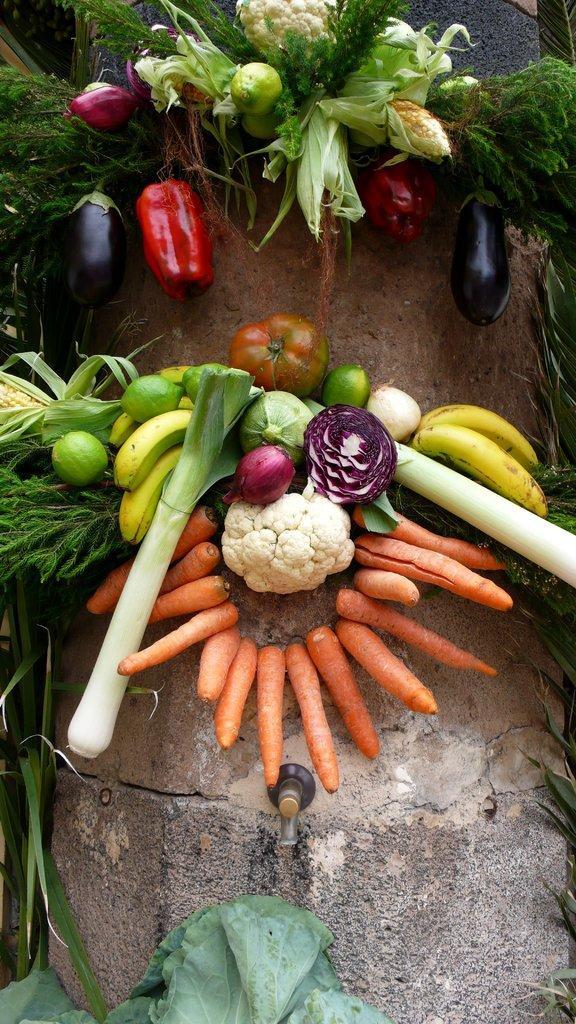In one or two sentences, can you explain what this image depicts? This image consists of raw vegetables. 